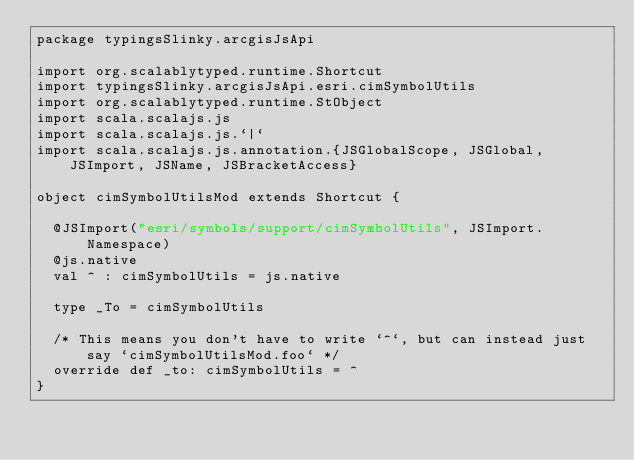Convert code to text. <code><loc_0><loc_0><loc_500><loc_500><_Scala_>package typingsSlinky.arcgisJsApi

import org.scalablytyped.runtime.Shortcut
import typingsSlinky.arcgisJsApi.esri.cimSymbolUtils
import org.scalablytyped.runtime.StObject
import scala.scalajs.js
import scala.scalajs.js.`|`
import scala.scalajs.js.annotation.{JSGlobalScope, JSGlobal, JSImport, JSName, JSBracketAccess}

object cimSymbolUtilsMod extends Shortcut {
  
  @JSImport("esri/symbols/support/cimSymbolUtils", JSImport.Namespace)
  @js.native
  val ^ : cimSymbolUtils = js.native
  
  type _To = cimSymbolUtils
  
  /* This means you don't have to write `^`, but can instead just say `cimSymbolUtilsMod.foo` */
  override def _to: cimSymbolUtils = ^
}
</code> 